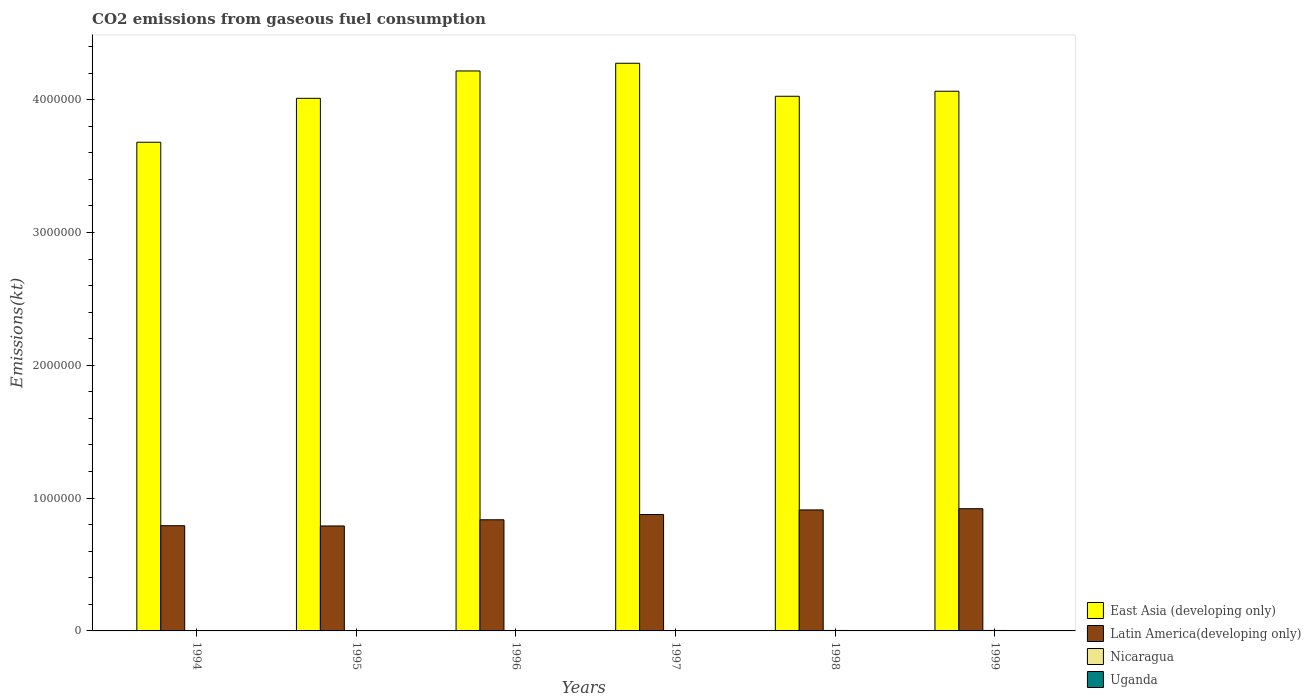How many different coloured bars are there?
Provide a succinct answer. 4. Are the number of bars per tick equal to the number of legend labels?
Provide a succinct answer. Yes. How many bars are there on the 3rd tick from the left?
Give a very brief answer. 4. In how many cases, is the number of bars for a given year not equal to the number of legend labels?
Your response must be concise. 0. What is the amount of CO2 emitted in Latin America(developing only) in 1994?
Offer a terse response. 7.92e+05. Across all years, what is the maximum amount of CO2 emitted in Uganda?
Provide a short and direct response. 1408.13. Across all years, what is the minimum amount of CO2 emitted in Uganda?
Offer a very short reply. 762.74. What is the total amount of CO2 emitted in Nicaragua in the graph?
Give a very brief answer. 1.84e+04. What is the difference between the amount of CO2 emitted in East Asia (developing only) in 1995 and that in 1996?
Make the answer very short. -2.06e+05. What is the difference between the amount of CO2 emitted in Latin America(developing only) in 1996 and the amount of CO2 emitted in Uganda in 1994?
Your answer should be compact. 8.36e+05. What is the average amount of CO2 emitted in East Asia (developing only) per year?
Provide a succinct answer. 4.04e+06. In the year 1995, what is the difference between the amount of CO2 emitted in East Asia (developing only) and amount of CO2 emitted in Nicaragua?
Your answer should be compact. 4.01e+06. In how many years, is the amount of CO2 emitted in Nicaragua greater than 3600000 kt?
Offer a very short reply. 0. What is the ratio of the amount of CO2 emitted in Latin America(developing only) in 1996 to that in 1998?
Keep it short and to the point. 0.92. What is the difference between the highest and the second highest amount of CO2 emitted in East Asia (developing only)?
Offer a very short reply. 5.80e+04. What is the difference between the highest and the lowest amount of CO2 emitted in Latin America(developing only)?
Ensure brevity in your answer.  1.30e+05. In how many years, is the amount of CO2 emitted in East Asia (developing only) greater than the average amount of CO2 emitted in East Asia (developing only) taken over all years?
Offer a terse response. 3. Is it the case that in every year, the sum of the amount of CO2 emitted in Latin America(developing only) and amount of CO2 emitted in Uganda is greater than the sum of amount of CO2 emitted in East Asia (developing only) and amount of CO2 emitted in Nicaragua?
Provide a succinct answer. Yes. What does the 4th bar from the left in 1995 represents?
Offer a terse response. Uganda. What does the 3rd bar from the right in 1995 represents?
Give a very brief answer. Latin America(developing only). How many bars are there?
Your response must be concise. 24. Are the values on the major ticks of Y-axis written in scientific E-notation?
Your response must be concise. No. Does the graph contain any zero values?
Provide a succinct answer. No. How many legend labels are there?
Your response must be concise. 4. How are the legend labels stacked?
Provide a short and direct response. Vertical. What is the title of the graph?
Your answer should be compact. CO2 emissions from gaseous fuel consumption. What is the label or title of the Y-axis?
Your answer should be compact. Emissions(kt). What is the Emissions(kt) of East Asia (developing only) in 1994?
Ensure brevity in your answer.  3.68e+06. What is the Emissions(kt) of Latin America(developing only) in 1994?
Provide a short and direct response. 7.92e+05. What is the Emissions(kt) in Nicaragua in 1994?
Your response must be concise. 2541.23. What is the Emissions(kt) in Uganda in 1994?
Give a very brief answer. 762.74. What is the Emissions(kt) of East Asia (developing only) in 1995?
Your answer should be very brief. 4.01e+06. What is the Emissions(kt) of Latin America(developing only) in 1995?
Provide a succinct answer. 7.90e+05. What is the Emissions(kt) of Nicaragua in 1995?
Keep it short and to the point. 2779.59. What is the Emissions(kt) of Uganda in 1995?
Your answer should be very brief. 993.76. What is the Emissions(kt) in East Asia (developing only) in 1996?
Keep it short and to the point. 4.22e+06. What is the Emissions(kt) of Latin America(developing only) in 1996?
Provide a short and direct response. 8.37e+05. What is the Emissions(kt) of Nicaragua in 1996?
Offer a terse response. 2874.93. What is the Emissions(kt) in Uganda in 1996?
Offer a very short reply. 1114.77. What is the Emissions(kt) of East Asia (developing only) in 1997?
Provide a succinct answer. 4.27e+06. What is the Emissions(kt) of Latin America(developing only) in 1997?
Provide a succinct answer. 8.76e+05. What is the Emissions(kt) in Nicaragua in 1997?
Make the answer very short. 3142.62. What is the Emissions(kt) of Uganda in 1997?
Your response must be concise. 1147.77. What is the Emissions(kt) in East Asia (developing only) in 1998?
Make the answer very short. 4.03e+06. What is the Emissions(kt) in Latin America(developing only) in 1998?
Provide a succinct answer. 9.11e+05. What is the Emissions(kt) in Nicaragua in 1998?
Your response must be concise. 3421.31. What is the Emissions(kt) of Uganda in 1998?
Your response must be concise. 1349.46. What is the Emissions(kt) of East Asia (developing only) in 1999?
Ensure brevity in your answer.  4.06e+06. What is the Emissions(kt) of Latin America(developing only) in 1999?
Give a very brief answer. 9.20e+05. What is the Emissions(kt) in Nicaragua in 1999?
Provide a succinct answer. 3626.66. What is the Emissions(kt) of Uganda in 1999?
Keep it short and to the point. 1408.13. Across all years, what is the maximum Emissions(kt) of East Asia (developing only)?
Give a very brief answer. 4.27e+06. Across all years, what is the maximum Emissions(kt) of Latin America(developing only)?
Make the answer very short. 9.20e+05. Across all years, what is the maximum Emissions(kt) in Nicaragua?
Ensure brevity in your answer.  3626.66. Across all years, what is the maximum Emissions(kt) of Uganda?
Your answer should be compact. 1408.13. Across all years, what is the minimum Emissions(kt) of East Asia (developing only)?
Ensure brevity in your answer.  3.68e+06. Across all years, what is the minimum Emissions(kt) of Latin America(developing only)?
Your answer should be compact. 7.90e+05. Across all years, what is the minimum Emissions(kt) in Nicaragua?
Your answer should be very brief. 2541.23. Across all years, what is the minimum Emissions(kt) in Uganda?
Make the answer very short. 762.74. What is the total Emissions(kt) of East Asia (developing only) in the graph?
Offer a terse response. 2.43e+07. What is the total Emissions(kt) of Latin America(developing only) in the graph?
Keep it short and to the point. 5.13e+06. What is the total Emissions(kt) in Nicaragua in the graph?
Provide a succinct answer. 1.84e+04. What is the total Emissions(kt) of Uganda in the graph?
Give a very brief answer. 6776.62. What is the difference between the Emissions(kt) in East Asia (developing only) in 1994 and that in 1995?
Make the answer very short. -3.31e+05. What is the difference between the Emissions(kt) in Latin America(developing only) in 1994 and that in 1995?
Offer a terse response. 1862.84. What is the difference between the Emissions(kt) in Nicaragua in 1994 and that in 1995?
Your answer should be very brief. -238.35. What is the difference between the Emissions(kt) in Uganda in 1994 and that in 1995?
Offer a terse response. -231.02. What is the difference between the Emissions(kt) of East Asia (developing only) in 1994 and that in 1996?
Your response must be concise. -5.37e+05. What is the difference between the Emissions(kt) in Latin America(developing only) in 1994 and that in 1996?
Offer a very short reply. -4.47e+04. What is the difference between the Emissions(kt) of Nicaragua in 1994 and that in 1996?
Keep it short and to the point. -333.7. What is the difference between the Emissions(kt) in Uganda in 1994 and that in 1996?
Provide a succinct answer. -352.03. What is the difference between the Emissions(kt) in East Asia (developing only) in 1994 and that in 1997?
Offer a very short reply. -5.95e+05. What is the difference between the Emissions(kt) in Latin America(developing only) in 1994 and that in 1997?
Keep it short and to the point. -8.41e+04. What is the difference between the Emissions(kt) in Nicaragua in 1994 and that in 1997?
Make the answer very short. -601.39. What is the difference between the Emissions(kt) of Uganda in 1994 and that in 1997?
Give a very brief answer. -385.04. What is the difference between the Emissions(kt) of East Asia (developing only) in 1994 and that in 1998?
Provide a short and direct response. -3.46e+05. What is the difference between the Emissions(kt) in Latin America(developing only) in 1994 and that in 1998?
Ensure brevity in your answer.  -1.19e+05. What is the difference between the Emissions(kt) in Nicaragua in 1994 and that in 1998?
Provide a short and direct response. -880.08. What is the difference between the Emissions(kt) in Uganda in 1994 and that in 1998?
Your answer should be very brief. -586.72. What is the difference between the Emissions(kt) of East Asia (developing only) in 1994 and that in 1999?
Keep it short and to the point. -3.84e+05. What is the difference between the Emissions(kt) in Latin America(developing only) in 1994 and that in 1999?
Offer a very short reply. -1.28e+05. What is the difference between the Emissions(kt) of Nicaragua in 1994 and that in 1999?
Your response must be concise. -1085.43. What is the difference between the Emissions(kt) in Uganda in 1994 and that in 1999?
Offer a terse response. -645.39. What is the difference between the Emissions(kt) of East Asia (developing only) in 1995 and that in 1996?
Your response must be concise. -2.06e+05. What is the difference between the Emissions(kt) in Latin America(developing only) in 1995 and that in 1996?
Keep it short and to the point. -4.65e+04. What is the difference between the Emissions(kt) of Nicaragua in 1995 and that in 1996?
Provide a short and direct response. -95.34. What is the difference between the Emissions(kt) of Uganda in 1995 and that in 1996?
Make the answer very short. -121.01. What is the difference between the Emissions(kt) of East Asia (developing only) in 1995 and that in 1997?
Offer a very short reply. -2.64e+05. What is the difference between the Emissions(kt) in Latin America(developing only) in 1995 and that in 1997?
Your answer should be very brief. -8.59e+04. What is the difference between the Emissions(kt) of Nicaragua in 1995 and that in 1997?
Provide a succinct answer. -363.03. What is the difference between the Emissions(kt) of Uganda in 1995 and that in 1997?
Provide a succinct answer. -154.01. What is the difference between the Emissions(kt) of East Asia (developing only) in 1995 and that in 1998?
Your answer should be very brief. -1.54e+04. What is the difference between the Emissions(kt) in Latin America(developing only) in 1995 and that in 1998?
Give a very brief answer. -1.21e+05. What is the difference between the Emissions(kt) of Nicaragua in 1995 and that in 1998?
Your answer should be very brief. -641.73. What is the difference between the Emissions(kt) of Uganda in 1995 and that in 1998?
Provide a succinct answer. -355.7. What is the difference between the Emissions(kt) of East Asia (developing only) in 1995 and that in 1999?
Your response must be concise. -5.33e+04. What is the difference between the Emissions(kt) of Latin America(developing only) in 1995 and that in 1999?
Your answer should be very brief. -1.30e+05. What is the difference between the Emissions(kt) of Nicaragua in 1995 and that in 1999?
Provide a succinct answer. -847.08. What is the difference between the Emissions(kt) in Uganda in 1995 and that in 1999?
Provide a succinct answer. -414.37. What is the difference between the Emissions(kt) in East Asia (developing only) in 1996 and that in 1997?
Provide a succinct answer. -5.80e+04. What is the difference between the Emissions(kt) in Latin America(developing only) in 1996 and that in 1997?
Give a very brief answer. -3.94e+04. What is the difference between the Emissions(kt) in Nicaragua in 1996 and that in 1997?
Your answer should be very brief. -267.69. What is the difference between the Emissions(kt) of Uganda in 1996 and that in 1997?
Make the answer very short. -33. What is the difference between the Emissions(kt) in East Asia (developing only) in 1996 and that in 1998?
Your response must be concise. 1.91e+05. What is the difference between the Emissions(kt) of Latin America(developing only) in 1996 and that in 1998?
Provide a short and direct response. -7.42e+04. What is the difference between the Emissions(kt) of Nicaragua in 1996 and that in 1998?
Ensure brevity in your answer.  -546.38. What is the difference between the Emissions(kt) in Uganda in 1996 and that in 1998?
Keep it short and to the point. -234.69. What is the difference between the Emissions(kt) of East Asia (developing only) in 1996 and that in 1999?
Make the answer very short. 1.53e+05. What is the difference between the Emissions(kt) in Latin America(developing only) in 1996 and that in 1999?
Keep it short and to the point. -8.33e+04. What is the difference between the Emissions(kt) in Nicaragua in 1996 and that in 1999?
Provide a short and direct response. -751.74. What is the difference between the Emissions(kt) in Uganda in 1996 and that in 1999?
Offer a very short reply. -293.36. What is the difference between the Emissions(kt) of East Asia (developing only) in 1997 and that in 1998?
Provide a short and direct response. 2.49e+05. What is the difference between the Emissions(kt) in Latin America(developing only) in 1997 and that in 1998?
Your answer should be very brief. -3.48e+04. What is the difference between the Emissions(kt) of Nicaragua in 1997 and that in 1998?
Your answer should be very brief. -278.69. What is the difference between the Emissions(kt) in Uganda in 1997 and that in 1998?
Ensure brevity in your answer.  -201.69. What is the difference between the Emissions(kt) of East Asia (developing only) in 1997 and that in 1999?
Provide a short and direct response. 2.11e+05. What is the difference between the Emissions(kt) in Latin America(developing only) in 1997 and that in 1999?
Your answer should be compact. -4.39e+04. What is the difference between the Emissions(kt) in Nicaragua in 1997 and that in 1999?
Ensure brevity in your answer.  -484.04. What is the difference between the Emissions(kt) of Uganda in 1997 and that in 1999?
Your answer should be very brief. -260.36. What is the difference between the Emissions(kt) in East Asia (developing only) in 1998 and that in 1999?
Offer a terse response. -3.79e+04. What is the difference between the Emissions(kt) in Latin America(developing only) in 1998 and that in 1999?
Give a very brief answer. -9050.16. What is the difference between the Emissions(kt) in Nicaragua in 1998 and that in 1999?
Your response must be concise. -205.35. What is the difference between the Emissions(kt) in Uganda in 1998 and that in 1999?
Make the answer very short. -58.67. What is the difference between the Emissions(kt) of East Asia (developing only) in 1994 and the Emissions(kt) of Latin America(developing only) in 1995?
Your response must be concise. 2.89e+06. What is the difference between the Emissions(kt) in East Asia (developing only) in 1994 and the Emissions(kt) in Nicaragua in 1995?
Provide a succinct answer. 3.68e+06. What is the difference between the Emissions(kt) in East Asia (developing only) in 1994 and the Emissions(kt) in Uganda in 1995?
Ensure brevity in your answer.  3.68e+06. What is the difference between the Emissions(kt) of Latin America(developing only) in 1994 and the Emissions(kt) of Nicaragua in 1995?
Give a very brief answer. 7.89e+05. What is the difference between the Emissions(kt) of Latin America(developing only) in 1994 and the Emissions(kt) of Uganda in 1995?
Give a very brief answer. 7.91e+05. What is the difference between the Emissions(kt) in Nicaragua in 1994 and the Emissions(kt) in Uganda in 1995?
Make the answer very short. 1547.47. What is the difference between the Emissions(kt) of East Asia (developing only) in 1994 and the Emissions(kt) of Latin America(developing only) in 1996?
Offer a terse response. 2.84e+06. What is the difference between the Emissions(kt) of East Asia (developing only) in 1994 and the Emissions(kt) of Nicaragua in 1996?
Give a very brief answer. 3.68e+06. What is the difference between the Emissions(kt) in East Asia (developing only) in 1994 and the Emissions(kt) in Uganda in 1996?
Offer a very short reply. 3.68e+06. What is the difference between the Emissions(kt) in Latin America(developing only) in 1994 and the Emissions(kt) in Nicaragua in 1996?
Offer a terse response. 7.89e+05. What is the difference between the Emissions(kt) in Latin America(developing only) in 1994 and the Emissions(kt) in Uganda in 1996?
Make the answer very short. 7.91e+05. What is the difference between the Emissions(kt) in Nicaragua in 1994 and the Emissions(kt) in Uganda in 1996?
Make the answer very short. 1426.46. What is the difference between the Emissions(kt) in East Asia (developing only) in 1994 and the Emissions(kt) in Latin America(developing only) in 1997?
Provide a succinct answer. 2.80e+06. What is the difference between the Emissions(kt) in East Asia (developing only) in 1994 and the Emissions(kt) in Nicaragua in 1997?
Provide a succinct answer. 3.68e+06. What is the difference between the Emissions(kt) in East Asia (developing only) in 1994 and the Emissions(kt) in Uganda in 1997?
Keep it short and to the point. 3.68e+06. What is the difference between the Emissions(kt) of Latin America(developing only) in 1994 and the Emissions(kt) of Nicaragua in 1997?
Make the answer very short. 7.89e+05. What is the difference between the Emissions(kt) in Latin America(developing only) in 1994 and the Emissions(kt) in Uganda in 1997?
Your answer should be very brief. 7.91e+05. What is the difference between the Emissions(kt) in Nicaragua in 1994 and the Emissions(kt) in Uganda in 1997?
Offer a terse response. 1393.46. What is the difference between the Emissions(kt) in East Asia (developing only) in 1994 and the Emissions(kt) in Latin America(developing only) in 1998?
Provide a short and direct response. 2.77e+06. What is the difference between the Emissions(kt) in East Asia (developing only) in 1994 and the Emissions(kt) in Nicaragua in 1998?
Keep it short and to the point. 3.68e+06. What is the difference between the Emissions(kt) in East Asia (developing only) in 1994 and the Emissions(kt) in Uganda in 1998?
Your response must be concise. 3.68e+06. What is the difference between the Emissions(kt) in Latin America(developing only) in 1994 and the Emissions(kt) in Nicaragua in 1998?
Offer a very short reply. 7.89e+05. What is the difference between the Emissions(kt) of Latin America(developing only) in 1994 and the Emissions(kt) of Uganda in 1998?
Provide a short and direct response. 7.91e+05. What is the difference between the Emissions(kt) in Nicaragua in 1994 and the Emissions(kt) in Uganda in 1998?
Offer a terse response. 1191.78. What is the difference between the Emissions(kt) in East Asia (developing only) in 1994 and the Emissions(kt) in Latin America(developing only) in 1999?
Provide a short and direct response. 2.76e+06. What is the difference between the Emissions(kt) of East Asia (developing only) in 1994 and the Emissions(kt) of Nicaragua in 1999?
Provide a short and direct response. 3.68e+06. What is the difference between the Emissions(kt) of East Asia (developing only) in 1994 and the Emissions(kt) of Uganda in 1999?
Offer a very short reply. 3.68e+06. What is the difference between the Emissions(kt) of Latin America(developing only) in 1994 and the Emissions(kt) of Nicaragua in 1999?
Keep it short and to the point. 7.88e+05. What is the difference between the Emissions(kt) of Latin America(developing only) in 1994 and the Emissions(kt) of Uganda in 1999?
Your answer should be very brief. 7.91e+05. What is the difference between the Emissions(kt) of Nicaragua in 1994 and the Emissions(kt) of Uganda in 1999?
Make the answer very short. 1133.1. What is the difference between the Emissions(kt) in East Asia (developing only) in 1995 and the Emissions(kt) in Latin America(developing only) in 1996?
Provide a short and direct response. 3.17e+06. What is the difference between the Emissions(kt) in East Asia (developing only) in 1995 and the Emissions(kt) in Nicaragua in 1996?
Offer a terse response. 4.01e+06. What is the difference between the Emissions(kt) in East Asia (developing only) in 1995 and the Emissions(kt) in Uganda in 1996?
Ensure brevity in your answer.  4.01e+06. What is the difference between the Emissions(kt) in Latin America(developing only) in 1995 and the Emissions(kt) in Nicaragua in 1996?
Make the answer very short. 7.87e+05. What is the difference between the Emissions(kt) in Latin America(developing only) in 1995 and the Emissions(kt) in Uganda in 1996?
Offer a very short reply. 7.89e+05. What is the difference between the Emissions(kt) of Nicaragua in 1995 and the Emissions(kt) of Uganda in 1996?
Your response must be concise. 1664.82. What is the difference between the Emissions(kt) in East Asia (developing only) in 1995 and the Emissions(kt) in Latin America(developing only) in 1997?
Give a very brief answer. 3.13e+06. What is the difference between the Emissions(kt) of East Asia (developing only) in 1995 and the Emissions(kt) of Nicaragua in 1997?
Offer a terse response. 4.01e+06. What is the difference between the Emissions(kt) of East Asia (developing only) in 1995 and the Emissions(kt) of Uganda in 1997?
Offer a terse response. 4.01e+06. What is the difference between the Emissions(kt) in Latin America(developing only) in 1995 and the Emissions(kt) in Nicaragua in 1997?
Offer a terse response. 7.87e+05. What is the difference between the Emissions(kt) in Latin America(developing only) in 1995 and the Emissions(kt) in Uganda in 1997?
Make the answer very short. 7.89e+05. What is the difference between the Emissions(kt) of Nicaragua in 1995 and the Emissions(kt) of Uganda in 1997?
Make the answer very short. 1631.82. What is the difference between the Emissions(kt) in East Asia (developing only) in 1995 and the Emissions(kt) in Latin America(developing only) in 1998?
Your answer should be very brief. 3.10e+06. What is the difference between the Emissions(kt) in East Asia (developing only) in 1995 and the Emissions(kt) in Nicaragua in 1998?
Offer a very short reply. 4.01e+06. What is the difference between the Emissions(kt) of East Asia (developing only) in 1995 and the Emissions(kt) of Uganda in 1998?
Offer a very short reply. 4.01e+06. What is the difference between the Emissions(kt) in Latin America(developing only) in 1995 and the Emissions(kt) in Nicaragua in 1998?
Keep it short and to the point. 7.87e+05. What is the difference between the Emissions(kt) in Latin America(developing only) in 1995 and the Emissions(kt) in Uganda in 1998?
Keep it short and to the point. 7.89e+05. What is the difference between the Emissions(kt) of Nicaragua in 1995 and the Emissions(kt) of Uganda in 1998?
Offer a terse response. 1430.13. What is the difference between the Emissions(kt) in East Asia (developing only) in 1995 and the Emissions(kt) in Latin America(developing only) in 1999?
Provide a short and direct response. 3.09e+06. What is the difference between the Emissions(kt) in East Asia (developing only) in 1995 and the Emissions(kt) in Nicaragua in 1999?
Keep it short and to the point. 4.01e+06. What is the difference between the Emissions(kt) in East Asia (developing only) in 1995 and the Emissions(kt) in Uganda in 1999?
Give a very brief answer. 4.01e+06. What is the difference between the Emissions(kt) of Latin America(developing only) in 1995 and the Emissions(kt) of Nicaragua in 1999?
Make the answer very short. 7.87e+05. What is the difference between the Emissions(kt) of Latin America(developing only) in 1995 and the Emissions(kt) of Uganda in 1999?
Offer a terse response. 7.89e+05. What is the difference between the Emissions(kt) of Nicaragua in 1995 and the Emissions(kt) of Uganda in 1999?
Offer a very short reply. 1371.46. What is the difference between the Emissions(kt) in East Asia (developing only) in 1996 and the Emissions(kt) in Latin America(developing only) in 1997?
Provide a succinct answer. 3.34e+06. What is the difference between the Emissions(kt) of East Asia (developing only) in 1996 and the Emissions(kt) of Nicaragua in 1997?
Offer a terse response. 4.21e+06. What is the difference between the Emissions(kt) in East Asia (developing only) in 1996 and the Emissions(kt) in Uganda in 1997?
Ensure brevity in your answer.  4.21e+06. What is the difference between the Emissions(kt) in Latin America(developing only) in 1996 and the Emissions(kt) in Nicaragua in 1997?
Keep it short and to the point. 8.34e+05. What is the difference between the Emissions(kt) of Latin America(developing only) in 1996 and the Emissions(kt) of Uganda in 1997?
Your response must be concise. 8.36e+05. What is the difference between the Emissions(kt) in Nicaragua in 1996 and the Emissions(kt) in Uganda in 1997?
Your answer should be compact. 1727.16. What is the difference between the Emissions(kt) of East Asia (developing only) in 1996 and the Emissions(kt) of Latin America(developing only) in 1998?
Provide a succinct answer. 3.30e+06. What is the difference between the Emissions(kt) of East Asia (developing only) in 1996 and the Emissions(kt) of Nicaragua in 1998?
Your answer should be very brief. 4.21e+06. What is the difference between the Emissions(kt) of East Asia (developing only) in 1996 and the Emissions(kt) of Uganda in 1998?
Offer a very short reply. 4.21e+06. What is the difference between the Emissions(kt) of Latin America(developing only) in 1996 and the Emissions(kt) of Nicaragua in 1998?
Your response must be concise. 8.33e+05. What is the difference between the Emissions(kt) of Latin America(developing only) in 1996 and the Emissions(kt) of Uganda in 1998?
Ensure brevity in your answer.  8.35e+05. What is the difference between the Emissions(kt) of Nicaragua in 1996 and the Emissions(kt) of Uganda in 1998?
Make the answer very short. 1525.47. What is the difference between the Emissions(kt) in East Asia (developing only) in 1996 and the Emissions(kt) in Latin America(developing only) in 1999?
Give a very brief answer. 3.30e+06. What is the difference between the Emissions(kt) of East Asia (developing only) in 1996 and the Emissions(kt) of Nicaragua in 1999?
Provide a short and direct response. 4.21e+06. What is the difference between the Emissions(kt) in East Asia (developing only) in 1996 and the Emissions(kt) in Uganda in 1999?
Provide a succinct answer. 4.21e+06. What is the difference between the Emissions(kt) in Latin America(developing only) in 1996 and the Emissions(kt) in Nicaragua in 1999?
Provide a short and direct response. 8.33e+05. What is the difference between the Emissions(kt) of Latin America(developing only) in 1996 and the Emissions(kt) of Uganda in 1999?
Ensure brevity in your answer.  8.35e+05. What is the difference between the Emissions(kt) in Nicaragua in 1996 and the Emissions(kt) in Uganda in 1999?
Offer a terse response. 1466.8. What is the difference between the Emissions(kt) of East Asia (developing only) in 1997 and the Emissions(kt) of Latin America(developing only) in 1998?
Give a very brief answer. 3.36e+06. What is the difference between the Emissions(kt) in East Asia (developing only) in 1997 and the Emissions(kt) in Nicaragua in 1998?
Your response must be concise. 4.27e+06. What is the difference between the Emissions(kt) of East Asia (developing only) in 1997 and the Emissions(kt) of Uganda in 1998?
Ensure brevity in your answer.  4.27e+06. What is the difference between the Emissions(kt) of Latin America(developing only) in 1997 and the Emissions(kt) of Nicaragua in 1998?
Keep it short and to the point. 8.73e+05. What is the difference between the Emissions(kt) in Latin America(developing only) in 1997 and the Emissions(kt) in Uganda in 1998?
Provide a short and direct response. 8.75e+05. What is the difference between the Emissions(kt) in Nicaragua in 1997 and the Emissions(kt) in Uganda in 1998?
Your answer should be compact. 1793.16. What is the difference between the Emissions(kt) of East Asia (developing only) in 1997 and the Emissions(kt) of Latin America(developing only) in 1999?
Offer a terse response. 3.35e+06. What is the difference between the Emissions(kt) in East Asia (developing only) in 1997 and the Emissions(kt) in Nicaragua in 1999?
Provide a short and direct response. 4.27e+06. What is the difference between the Emissions(kt) of East Asia (developing only) in 1997 and the Emissions(kt) of Uganda in 1999?
Ensure brevity in your answer.  4.27e+06. What is the difference between the Emissions(kt) of Latin America(developing only) in 1997 and the Emissions(kt) of Nicaragua in 1999?
Make the answer very short. 8.73e+05. What is the difference between the Emissions(kt) of Latin America(developing only) in 1997 and the Emissions(kt) of Uganda in 1999?
Your answer should be compact. 8.75e+05. What is the difference between the Emissions(kt) in Nicaragua in 1997 and the Emissions(kt) in Uganda in 1999?
Make the answer very short. 1734.49. What is the difference between the Emissions(kt) of East Asia (developing only) in 1998 and the Emissions(kt) of Latin America(developing only) in 1999?
Give a very brief answer. 3.11e+06. What is the difference between the Emissions(kt) of East Asia (developing only) in 1998 and the Emissions(kt) of Nicaragua in 1999?
Offer a terse response. 4.02e+06. What is the difference between the Emissions(kt) of East Asia (developing only) in 1998 and the Emissions(kt) of Uganda in 1999?
Make the answer very short. 4.02e+06. What is the difference between the Emissions(kt) of Latin America(developing only) in 1998 and the Emissions(kt) of Nicaragua in 1999?
Provide a short and direct response. 9.07e+05. What is the difference between the Emissions(kt) of Latin America(developing only) in 1998 and the Emissions(kt) of Uganda in 1999?
Keep it short and to the point. 9.10e+05. What is the difference between the Emissions(kt) of Nicaragua in 1998 and the Emissions(kt) of Uganda in 1999?
Offer a very short reply. 2013.18. What is the average Emissions(kt) of East Asia (developing only) per year?
Ensure brevity in your answer.  4.04e+06. What is the average Emissions(kt) in Latin America(developing only) per year?
Give a very brief answer. 8.54e+05. What is the average Emissions(kt) in Nicaragua per year?
Provide a succinct answer. 3064.39. What is the average Emissions(kt) of Uganda per year?
Ensure brevity in your answer.  1129.44. In the year 1994, what is the difference between the Emissions(kt) in East Asia (developing only) and Emissions(kt) in Latin America(developing only)?
Make the answer very short. 2.89e+06. In the year 1994, what is the difference between the Emissions(kt) of East Asia (developing only) and Emissions(kt) of Nicaragua?
Give a very brief answer. 3.68e+06. In the year 1994, what is the difference between the Emissions(kt) in East Asia (developing only) and Emissions(kt) in Uganda?
Provide a short and direct response. 3.68e+06. In the year 1994, what is the difference between the Emissions(kt) in Latin America(developing only) and Emissions(kt) in Nicaragua?
Your answer should be compact. 7.90e+05. In the year 1994, what is the difference between the Emissions(kt) in Latin America(developing only) and Emissions(kt) in Uganda?
Ensure brevity in your answer.  7.91e+05. In the year 1994, what is the difference between the Emissions(kt) in Nicaragua and Emissions(kt) in Uganda?
Give a very brief answer. 1778.49. In the year 1995, what is the difference between the Emissions(kt) in East Asia (developing only) and Emissions(kt) in Latin America(developing only)?
Your answer should be very brief. 3.22e+06. In the year 1995, what is the difference between the Emissions(kt) of East Asia (developing only) and Emissions(kt) of Nicaragua?
Your response must be concise. 4.01e+06. In the year 1995, what is the difference between the Emissions(kt) in East Asia (developing only) and Emissions(kt) in Uganda?
Provide a short and direct response. 4.01e+06. In the year 1995, what is the difference between the Emissions(kt) of Latin America(developing only) and Emissions(kt) of Nicaragua?
Give a very brief answer. 7.87e+05. In the year 1995, what is the difference between the Emissions(kt) of Latin America(developing only) and Emissions(kt) of Uganda?
Offer a terse response. 7.89e+05. In the year 1995, what is the difference between the Emissions(kt) of Nicaragua and Emissions(kt) of Uganda?
Keep it short and to the point. 1785.83. In the year 1996, what is the difference between the Emissions(kt) in East Asia (developing only) and Emissions(kt) in Latin America(developing only)?
Provide a short and direct response. 3.38e+06. In the year 1996, what is the difference between the Emissions(kt) of East Asia (developing only) and Emissions(kt) of Nicaragua?
Your response must be concise. 4.21e+06. In the year 1996, what is the difference between the Emissions(kt) in East Asia (developing only) and Emissions(kt) in Uganda?
Your response must be concise. 4.21e+06. In the year 1996, what is the difference between the Emissions(kt) of Latin America(developing only) and Emissions(kt) of Nicaragua?
Ensure brevity in your answer.  8.34e+05. In the year 1996, what is the difference between the Emissions(kt) in Latin America(developing only) and Emissions(kt) in Uganda?
Your answer should be compact. 8.36e+05. In the year 1996, what is the difference between the Emissions(kt) in Nicaragua and Emissions(kt) in Uganda?
Offer a very short reply. 1760.16. In the year 1997, what is the difference between the Emissions(kt) of East Asia (developing only) and Emissions(kt) of Latin America(developing only)?
Your response must be concise. 3.40e+06. In the year 1997, what is the difference between the Emissions(kt) of East Asia (developing only) and Emissions(kt) of Nicaragua?
Your answer should be compact. 4.27e+06. In the year 1997, what is the difference between the Emissions(kt) in East Asia (developing only) and Emissions(kt) in Uganda?
Your response must be concise. 4.27e+06. In the year 1997, what is the difference between the Emissions(kt) of Latin America(developing only) and Emissions(kt) of Nicaragua?
Your answer should be very brief. 8.73e+05. In the year 1997, what is the difference between the Emissions(kt) in Latin America(developing only) and Emissions(kt) in Uganda?
Offer a very short reply. 8.75e+05. In the year 1997, what is the difference between the Emissions(kt) of Nicaragua and Emissions(kt) of Uganda?
Make the answer very short. 1994.85. In the year 1998, what is the difference between the Emissions(kt) in East Asia (developing only) and Emissions(kt) in Latin America(developing only)?
Your answer should be very brief. 3.11e+06. In the year 1998, what is the difference between the Emissions(kt) in East Asia (developing only) and Emissions(kt) in Nicaragua?
Offer a terse response. 4.02e+06. In the year 1998, what is the difference between the Emissions(kt) in East Asia (developing only) and Emissions(kt) in Uganda?
Offer a very short reply. 4.02e+06. In the year 1998, what is the difference between the Emissions(kt) of Latin America(developing only) and Emissions(kt) of Nicaragua?
Your answer should be very brief. 9.08e+05. In the year 1998, what is the difference between the Emissions(kt) of Latin America(developing only) and Emissions(kt) of Uganda?
Keep it short and to the point. 9.10e+05. In the year 1998, what is the difference between the Emissions(kt) of Nicaragua and Emissions(kt) of Uganda?
Offer a terse response. 2071.86. In the year 1999, what is the difference between the Emissions(kt) in East Asia (developing only) and Emissions(kt) in Latin America(developing only)?
Give a very brief answer. 3.14e+06. In the year 1999, what is the difference between the Emissions(kt) in East Asia (developing only) and Emissions(kt) in Nicaragua?
Give a very brief answer. 4.06e+06. In the year 1999, what is the difference between the Emissions(kt) in East Asia (developing only) and Emissions(kt) in Uganda?
Ensure brevity in your answer.  4.06e+06. In the year 1999, what is the difference between the Emissions(kt) of Latin America(developing only) and Emissions(kt) of Nicaragua?
Your answer should be very brief. 9.16e+05. In the year 1999, what is the difference between the Emissions(kt) in Latin America(developing only) and Emissions(kt) in Uganda?
Keep it short and to the point. 9.19e+05. In the year 1999, what is the difference between the Emissions(kt) in Nicaragua and Emissions(kt) in Uganda?
Your answer should be very brief. 2218.53. What is the ratio of the Emissions(kt) of East Asia (developing only) in 1994 to that in 1995?
Your answer should be compact. 0.92. What is the ratio of the Emissions(kt) of Nicaragua in 1994 to that in 1995?
Keep it short and to the point. 0.91. What is the ratio of the Emissions(kt) of Uganda in 1994 to that in 1995?
Provide a short and direct response. 0.77. What is the ratio of the Emissions(kt) in East Asia (developing only) in 1994 to that in 1996?
Your response must be concise. 0.87. What is the ratio of the Emissions(kt) in Latin America(developing only) in 1994 to that in 1996?
Offer a very short reply. 0.95. What is the ratio of the Emissions(kt) in Nicaragua in 1994 to that in 1996?
Provide a succinct answer. 0.88. What is the ratio of the Emissions(kt) in Uganda in 1994 to that in 1996?
Your answer should be compact. 0.68. What is the ratio of the Emissions(kt) of East Asia (developing only) in 1994 to that in 1997?
Make the answer very short. 0.86. What is the ratio of the Emissions(kt) in Latin America(developing only) in 1994 to that in 1997?
Your response must be concise. 0.9. What is the ratio of the Emissions(kt) of Nicaragua in 1994 to that in 1997?
Keep it short and to the point. 0.81. What is the ratio of the Emissions(kt) in Uganda in 1994 to that in 1997?
Provide a succinct answer. 0.66. What is the ratio of the Emissions(kt) in East Asia (developing only) in 1994 to that in 1998?
Offer a terse response. 0.91. What is the ratio of the Emissions(kt) in Latin America(developing only) in 1994 to that in 1998?
Keep it short and to the point. 0.87. What is the ratio of the Emissions(kt) of Nicaragua in 1994 to that in 1998?
Your answer should be compact. 0.74. What is the ratio of the Emissions(kt) of Uganda in 1994 to that in 1998?
Keep it short and to the point. 0.57. What is the ratio of the Emissions(kt) of East Asia (developing only) in 1994 to that in 1999?
Your answer should be very brief. 0.91. What is the ratio of the Emissions(kt) of Latin America(developing only) in 1994 to that in 1999?
Ensure brevity in your answer.  0.86. What is the ratio of the Emissions(kt) in Nicaragua in 1994 to that in 1999?
Your answer should be compact. 0.7. What is the ratio of the Emissions(kt) of Uganda in 1994 to that in 1999?
Provide a succinct answer. 0.54. What is the ratio of the Emissions(kt) in East Asia (developing only) in 1995 to that in 1996?
Offer a terse response. 0.95. What is the ratio of the Emissions(kt) in Nicaragua in 1995 to that in 1996?
Provide a short and direct response. 0.97. What is the ratio of the Emissions(kt) in Uganda in 1995 to that in 1996?
Provide a short and direct response. 0.89. What is the ratio of the Emissions(kt) of East Asia (developing only) in 1995 to that in 1997?
Make the answer very short. 0.94. What is the ratio of the Emissions(kt) in Latin America(developing only) in 1995 to that in 1997?
Your answer should be compact. 0.9. What is the ratio of the Emissions(kt) in Nicaragua in 1995 to that in 1997?
Keep it short and to the point. 0.88. What is the ratio of the Emissions(kt) in Uganda in 1995 to that in 1997?
Your answer should be very brief. 0.87. What is the ratio of the Emissions(kt) in Latin America(developing only) in 1995 to that in 1998?
Offer a very short reply. 0.87. What is the ratio of the Emissions(kt) of Nicaragua in 1995 to that in 1998?
Make the answer very short. 0.81. What is the ratio of the Emissions(kt) in Uganda in 1995 to that in 1998?
Offer a terse response. 0.74. What is the ratio of the Emissions(kt) of East Asia (developing only) in 1995 to that in 1999?
Your answer should be very brief. 0.99. What is the ratio of the Emissions(kt) of Latin America(developing only) in 1995 to that in 1999?
Make the answer very short. 0.86. What is the ratio of the Emissions(kt) in Nicaragua in 1995 to that in 1999?
Keep it short and to the point. 0.77. What is the ratio of the Emissions(kt) in Uganda in 1995 to that in 1999?
Keep it short and to the point. 0.71. What is the ratio of the Emissions(kt) in East Asia (developing only) in 1996 to that in 1997?
Keep it short and to the point. 0.99. What is the ratio of the Emissions(kt) of Latin America(developing only) in 1996 to that in 1997?
Provide a short and direct response. 0.95. What is the ratio of the Emissions(kt) of Nicaragua in 1996 to that in 1997?
Your response must be concise. 0.91. What is the ratio of the Emissions(kt) of Uganda in 1996 to that in 1997?
Give a very brief answer. 0.97. What is the ratio of the Emissions(kt) of East Asia (developing only) in 1996 to that in 1998?
Give a very brief answer. 1.05. What is the ratio of the Emissions(kt) of Latin America(developing only) in 1996 to that in 1998?
Your response must be concise. 0.92. What is the ratio of the Emissions(kt) in Nicaragua in 1996 to that in 1998?
Offer a very short reply. 0.84. What is the ratio of the Emissions(kt) in Uganda in 1996 to that in 1998?
Provide a succinct answer. 0.83. What is the ratio of the Emissions(kt) in East Asia (developing only) in 1996 to that in 1999?
Your answer should be compact. 1.04. What is the ratio of the Emissions(kt) in Latin America(developing only) in 1996 to that in 1999?
Make the answer very short. 0.91. What is the ratio of the Emissions(kt) in Nicaragua in 1996 to that in 1999?
Offer a terse response. 0.79. What is the ratio of the Emissions(kt) of Uganda in 1996 to that in 1999?
Ensure brevity in your answer.  0.79. What is the ratio of the Emissions(kt) of East Asia (developing only) in 1997 to that in 1998?
Provide a short and direct response. 1.06. What is the ratio of the Emissions(kt) in Latin America(developing only) in 1997 to that in 1998?
Give a very brief answer. 0.96. What is the ratio of the Emissions(kt) in Nicaragua in 1997 to that in 1998?
Give a very brief answer. 0.92. What is the ratio of the Emissions(kt) of Uganda in 1997 to that in 1998?
Your answer should be very brief. 0.85. What is the ratio of the Emissions(kt) of East Asia (developing only) in 1997 to that in 1999?
Your response must be concise. 1.05. What is the ratio of the Emissions(kt) of Latin America(developing only) in 1997 to that in 1999?
Make the answer very short. 0.95. What is the ratio of the Emissions(kt) of Nicaragua in 1997 to that in 1999?
Your answer should be compact. 0.87. What is the ratio of the Emissions(kt) in Uganda in 1997 to that in 1999?
Give a very brief answer. 0.82. What is the ratio of the Emissions(kt) of Latin America(developing only) in 1998 to that in 1999?
Provide a short and direct response. 0.99. What is the ratio of the Emissions(kt) of Nicaragua in 1998 to that in 1999?
Your answer should be very brief. 0.94. What is the difference between the highest and the second highest Emissions(kt) of East Asia (developing only)?
Give a very brief answer. 5.80e+04. What is the difference between the highest and the second highest Emissions(kt) in Latin America(developing only)?
Provide a short and direct response. 9050.16. What is the difference between the highest and the second highest Emissions(kt) in Nicaragua?
Offer a very short reply. 205.35. What is the difference between the highest and the second highest Emissions(kt) of Uganda?
Provide a succinct answer. 58.67. What is the difference between the highest and the lowest Emissions(kt) in East Asia (developing only)?
Keep it short and to the point. 5.95e+05. What is the difference between the highest and the lowest Emissions(kt) in Latin America(developing only)?
Provide a succinct answer. 1.30e+05. What is the difference between the highest and the lowest Emissions(kt) in Nicaragua?
Ensure brevity in your answer.  1085.43. What is the difference between the highest and the lowest Emissions(kt) in Uganda?
Provide a succinct answer. 645.39. 